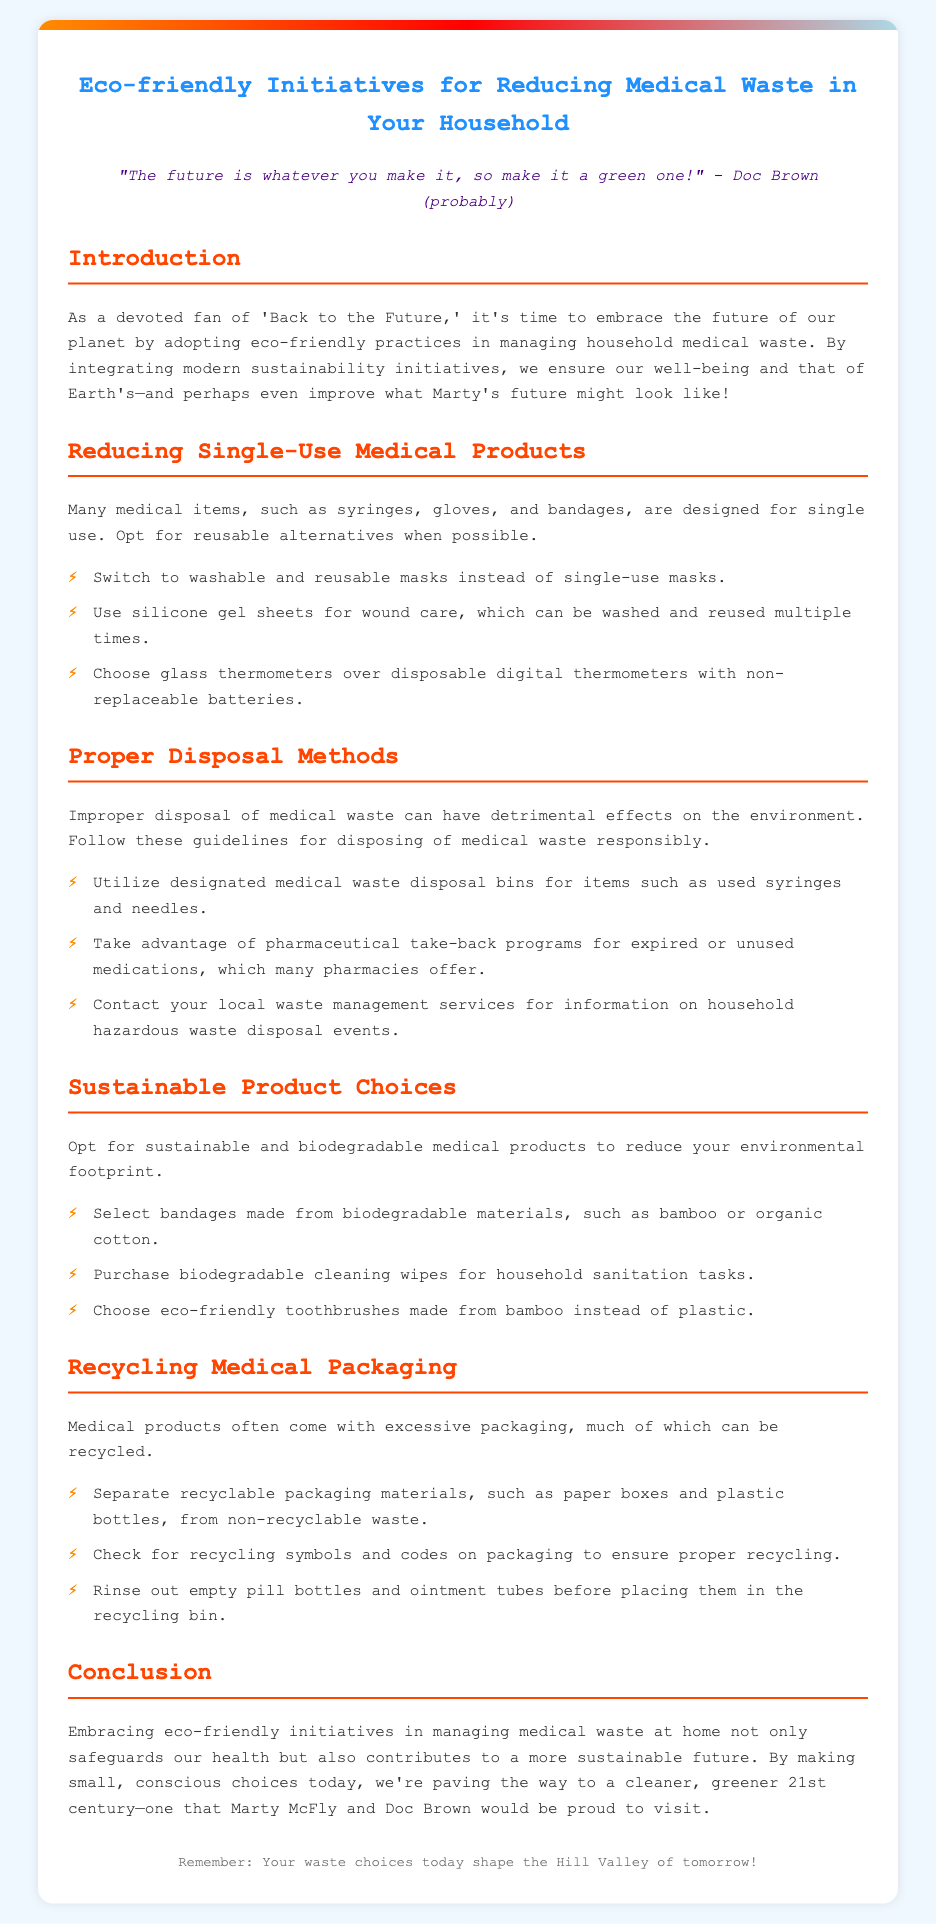what is the title of the document? The title of the document is provided in the <title> tag in the HTML, which is "Eco-friendly Medical Waste Reduction".
Answer: Eco-friendly Medical Waste Reduction who is quoted in the document? The quote is attributed to Doc Brown, a character from the 'Back to the Future' series, as indicated in the quote section.
Answer: Doc Brown what type of masks are recommended instead of single-use masks? The document suggests "washable and reusable masks" as an alternative to single-use masks.
Answer: washable and reusable masks what should you utilize for disposing of used syringes? The document advises using "designated medical waste disposal bins" for the disposal of used syringes.
Answer: designated medical waste disposal bins which materials are suggested for biodegradable bandages? Biodegradable bandages are suggested to be made from materials like "bamboo or organic cotton" according to the document.
Answer: bamboo or organic cotton what is one method for recycling medical packaging mentioned? The document mentions "rinse out empty pill bottles and ointment tubes" as a method for recycling medical packaging.
Answer: rinse out empty pill bottles and ointment tubes what is the first section listed in the document? The first section listed is "Introduction," which outlines the document's purpose.
Answer: Introduction how many guidelines are provided for proper disposal methods? The document lists three guidelines for proper disposal methods.
Answer: three what is the central theme of the document? The central theme revolves around "eco-friendly initiatives for reducing medical waste in your household."
Answer: eco-friendly initiatives for reducing medical waste in your household 